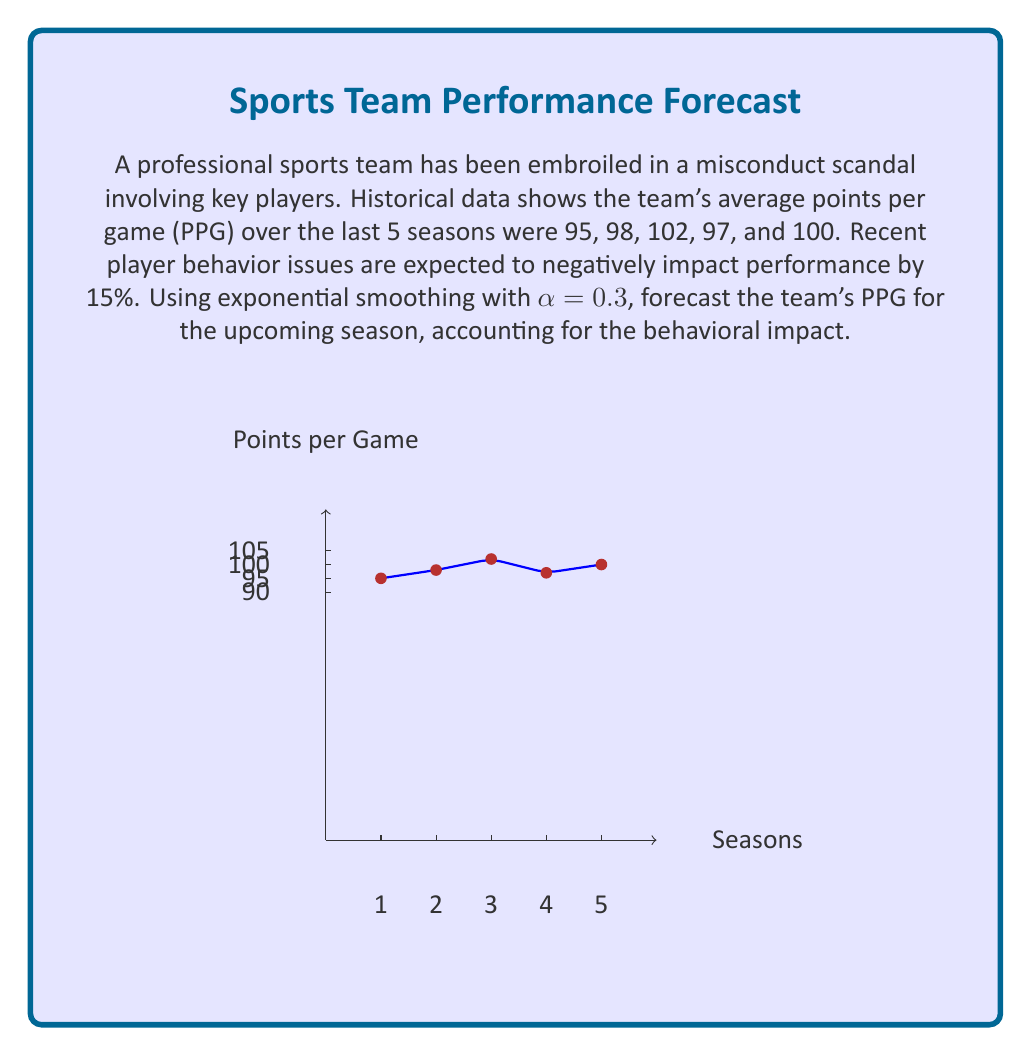Help me with this question. To solve this problem, we'll use the following steps:

1) First, we need to calculate the exponential smoothing forecast without considering the behavioral impact:

   Let $F_t$ be the forecast for period t, and $Y_t$ be the actual value for period t.
   The exponential smoothing formula is: $F_{t+1} = αY_t + (1-α)F_t$

   Given α = 0.3, we calculate:
   $F_2 = 0.3(95) + 0.7(95) = 95$
   $F_3 = 0.3(98) + 0.7(95) = 95.9$
   $F_4 = 0.3(102) + 0.7(95.9) = 97.73$
   $F_5 = 0.3(97) + 0.7(97.73) = 97.511$
   $F_6 = 0.3(100) + 0.7(97.511) = 98.2577$

2) The forecast for the upcoming season (without behavioral impact) is 98.2577 PPG.

3) Now, we need to account for the 15% negative impact due to behavioral issues:
   $98.2577 * (1 - 0.15) = 98.2577 * 0.85 = 83.51905$

Therefore, the forecast for the upcoming season, considering the behavioral impact, is approximately 83.52 PPG.
Answer: 83.52 PPG 